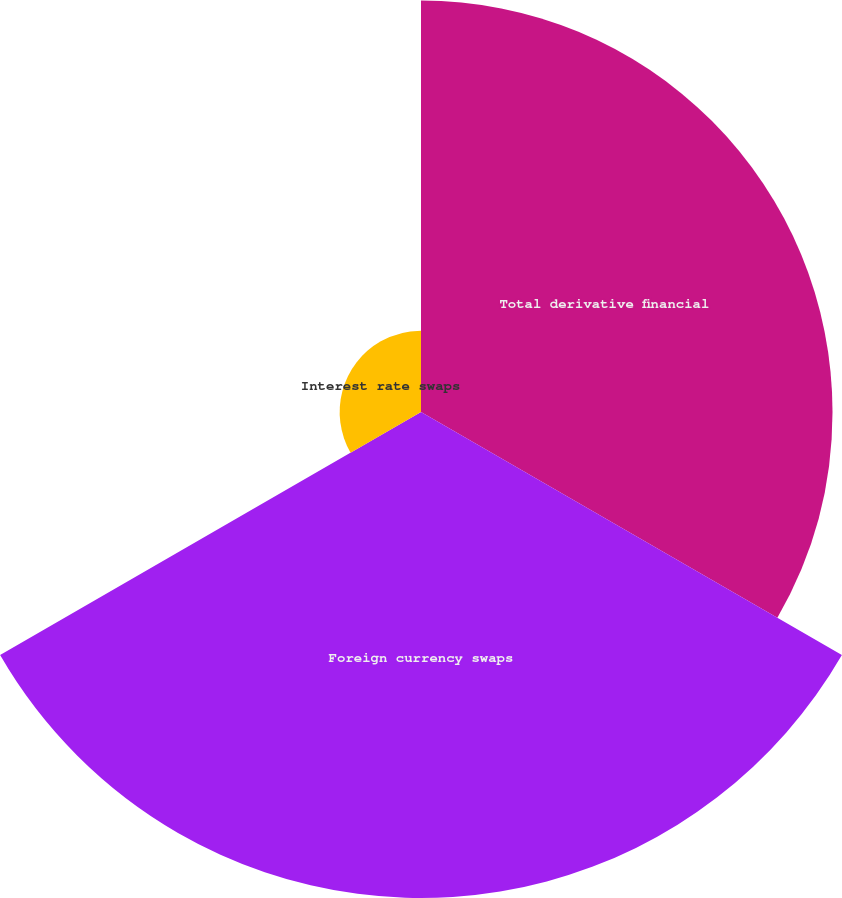Convert chart. <chart><loc_0><loc_0><loc_500><loc_500><pie_chart><fcel>Total derivative financial<fcel>Foreign currency swaps<fcel>Interest rate swaps<nl><fcel>42.04%<fcel>49.65%<fcel>8.31%<nl></chart> 